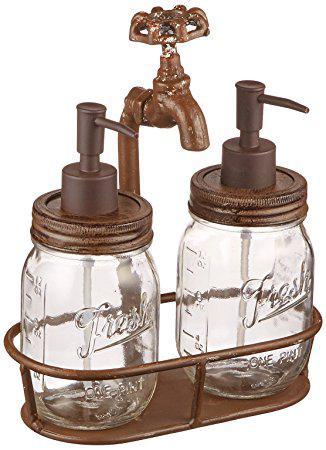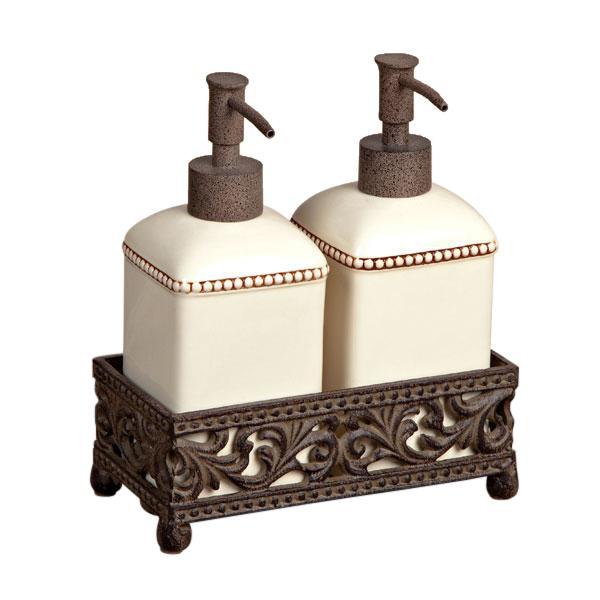The first image is the image on the left, the second image is the image on the right. Assess this claim about the two images: "None of the objects are brown in color". Correct or not? Answer yes or no. No. 